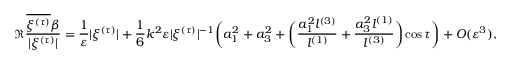<formula> <loc_0><loc_0><loc_500><loc_500>\Re \frac { \overline { { { \xi } ^ { ( \tau ) } } } \beta } { | \xi ^ { ( \tau ) } | } = \frac { 1 } \varepsilon } | \xi ^ { ( \tau ) } | + \frac { 1 } { 6 } k ^ { 2 } \varepsilon | \xi ^ { ( \tau ) } | ^ { - 1 } \left ( a _ { 1 } ^ { 2 } + a _ { 3 } ^ { 2 } + \left ( \frac { a _ { 1 } ^ { 2 } l ^ { ( 3 ) } } { l ^ { ( 1 ) } } + \frac { a _ { 3 } ^ { 2 } l ^ { ( 1 ) } } { l ^ { ( 3 ) } } \right ) \cos \tau \right ) + O ( \varepsilon ^ { 3 } ) ,</formula> 